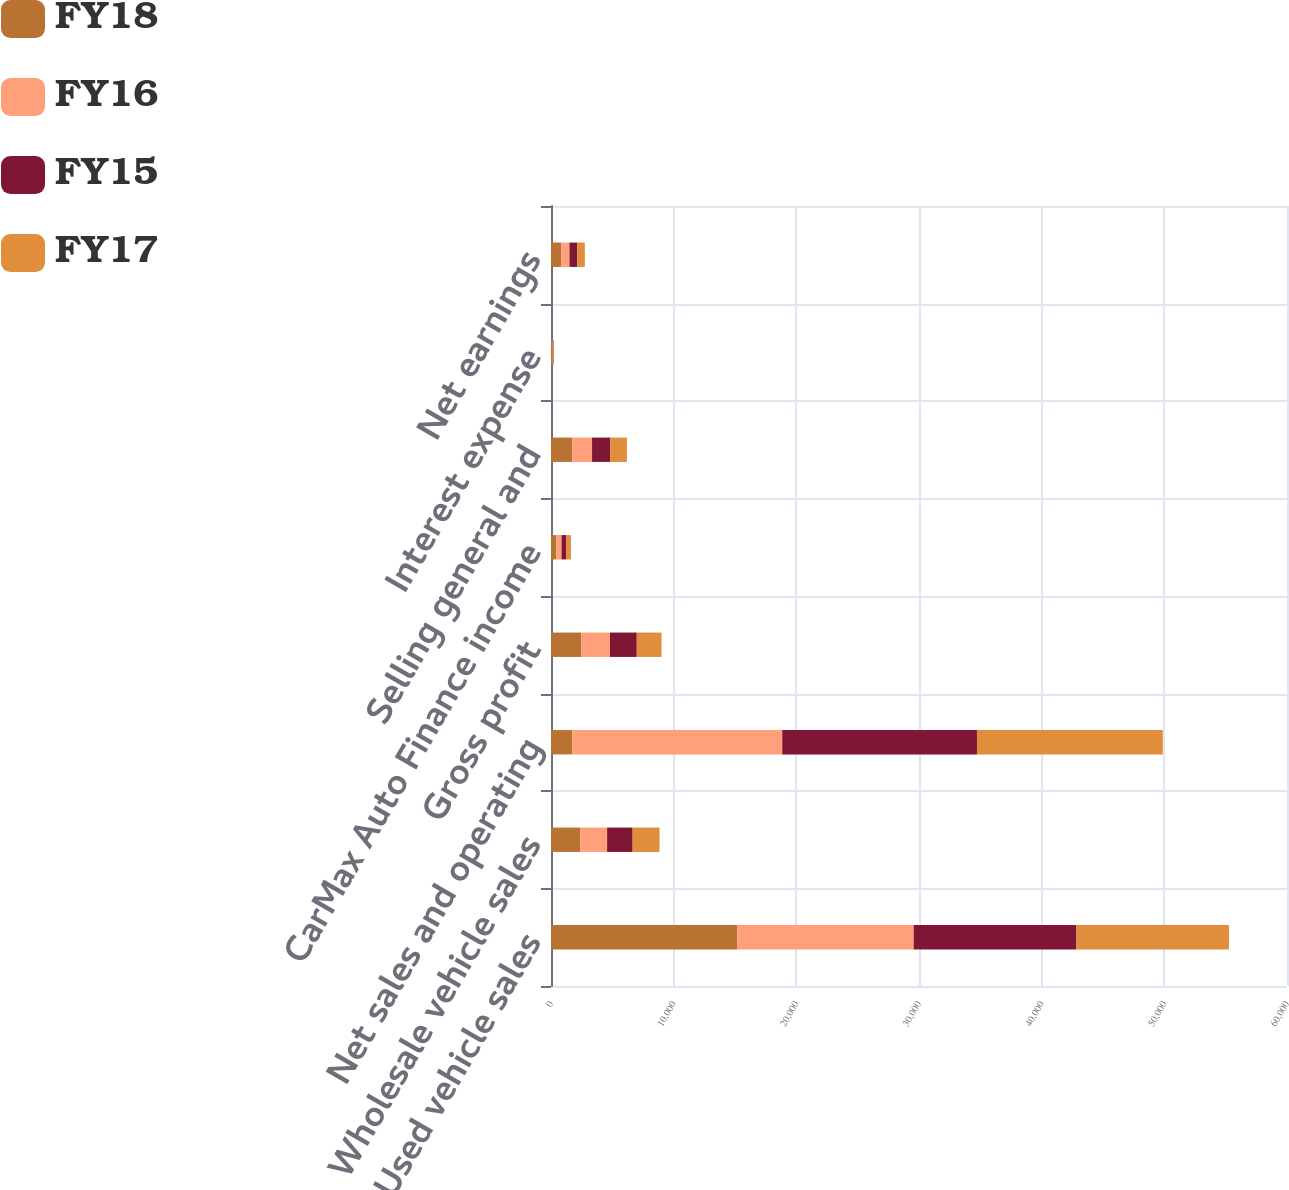Convert chart to OTSL. <chart><loc_0><loc_0><loc_500><loc_500><stacked_bar_chart><ecel><fcel>Used vehicle sales<fcel>Wholesale vehicle sales<fcel>Net sales and operating<fcel>Gross profit<fcel>CarMax Auto Finance income<fcel>Selling general and<fcel>Interest expense<fcel>Net earnings<nl><fcel>FY18<fcel>15172.8<fcel>2393<fcel>1730.3<fcel>2480.6<fcel>438.7<fcel>1730.3<fcel>75.8<fcel>842.4<nl><fcel>FY16<fcel>14392.4<fcel>2181.2<fcel>17120.2<fcel>2328.9<fcel>421.2<fcel>1617.1<fcel>70.7<fcel>664.1<nl><fcel>FY15<fcel>13270.7<fcel>2082.5<fcel>15875.1<fcel>2183.3<fcel>369<fcel>1488.5<fcel>56.4<fcel>627<nl><fcel>FY17<fcel>12439.4<fcel>2188.3<fcel>15149.7<fcel>2018.8<fcel>392<fcel>1351.9<fcel>36.4<fcel>623.4<nl></chart> 